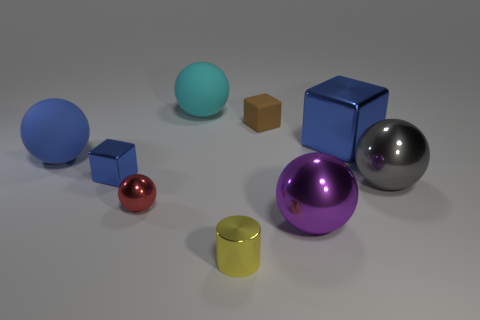What is the shape of the blue thing that is the same size as the shiny cylinder?
Provide a succinct answer. Cube. There is a big ball that is the same color as the big metal cube; what is it made of?
Give a very brief answer. Rubber. There is a block that is both left of the purple metallic object and in front of the brown cube; how big is it?
Your answer should be very brief. Small. What number of rubber things are purple things or large spheres?
Provide a succinct answer. 2. Is the number of big gray spheres that are to the right of the big purple thing greater than the number of big red spheres?
Your answer should be very brief. Yes. There is a small cube on the right side of the cyan thing; what is its material?
Give a very brief answer. Rubber. How many other cyan balls are made of the same material as the small sphere?
Your answer should be very brief. 0. What shape is the rubber object that is to the left of the tiny metal cylinder and in front of the cyan object?
Provide a succinct answer. Sphere. How many things are big spheres on the right side of the tiny rubber thing or objects that are left of the small matte block?
Offer a terse response. 7. Is the number of tiny blue metallic blocks that are right of the brown cube the same as the number of large objects that are on the right side of the blue matte ball?
Make the answer very short. No. 